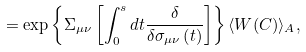<formula> <loc_0><loc_0><loc_500><loc_500>= \exp \left \{ \Sigma _ { \mu \nu } \left [ \int _ { 0 } ^ { s } d t \frac { \delta } { \delta \sigma _ { \mu \nu } \left ( t \right ) } \right ] \right \} \langle W ( C ) \rangle _ { A } ,</formula> 